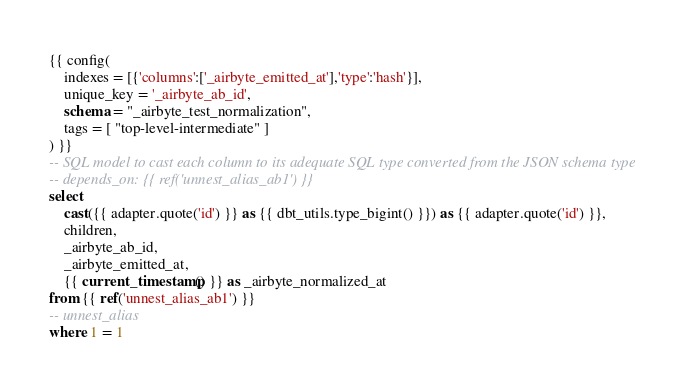<code> <loc_0><loc_0><loc_500><loc_500><_SQL_>{{ config(
    indexes = [{'columns':['_airbyte_emitted_at'],'type':'hash'}],
    unique_key = '_airbyte_ab_id',
    schema = "_airbyte_test_normalization",
    tags = [ "top-level-intermediate" ]
) }}
-- SQL model to cast each column to its adequate SQL type converted from the JSON schema type
-- depends_on: {{ ref('unnest_alias_ab1') }}
select
    cast({{ adapter.quote('id') }} as {{ dbt_utils.type_bigint() }}) as {{ adapter.quote('id') }},
    children,
    _airbyte_ab_id,
    _airbyte_emitted_at,
    {{ current_timestamp() }} as _airbyte_normalized_at
from {{ ref('unnest_alias_ab1') }}
-- unnest_alias
where 1 = 1

</code> 